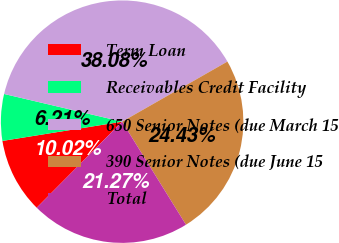Convert chart. <chart><loc_0><loc_0><loc_500><loc_500><pie_chart><fcel>Term Loan<fcel>Receivables Credit Facility<fcel>650 Senior Notes (due March 15<fcel>390 Senior Notes (due June 15<fcel>Total<nl><fcel>10.02%<fcel>6.21%<fcel>38.08%<fcel>24.43%<fcel>21.27%<nl></chart> 